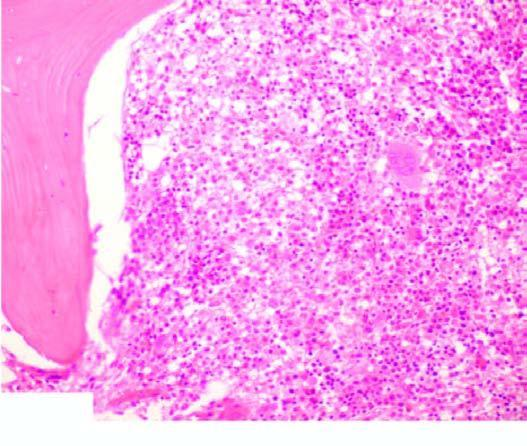what does a peripheral blood show?
Answer the question using a single word or phrase. Presence of a leukaemic cells with hairy cytoplasmic projections 